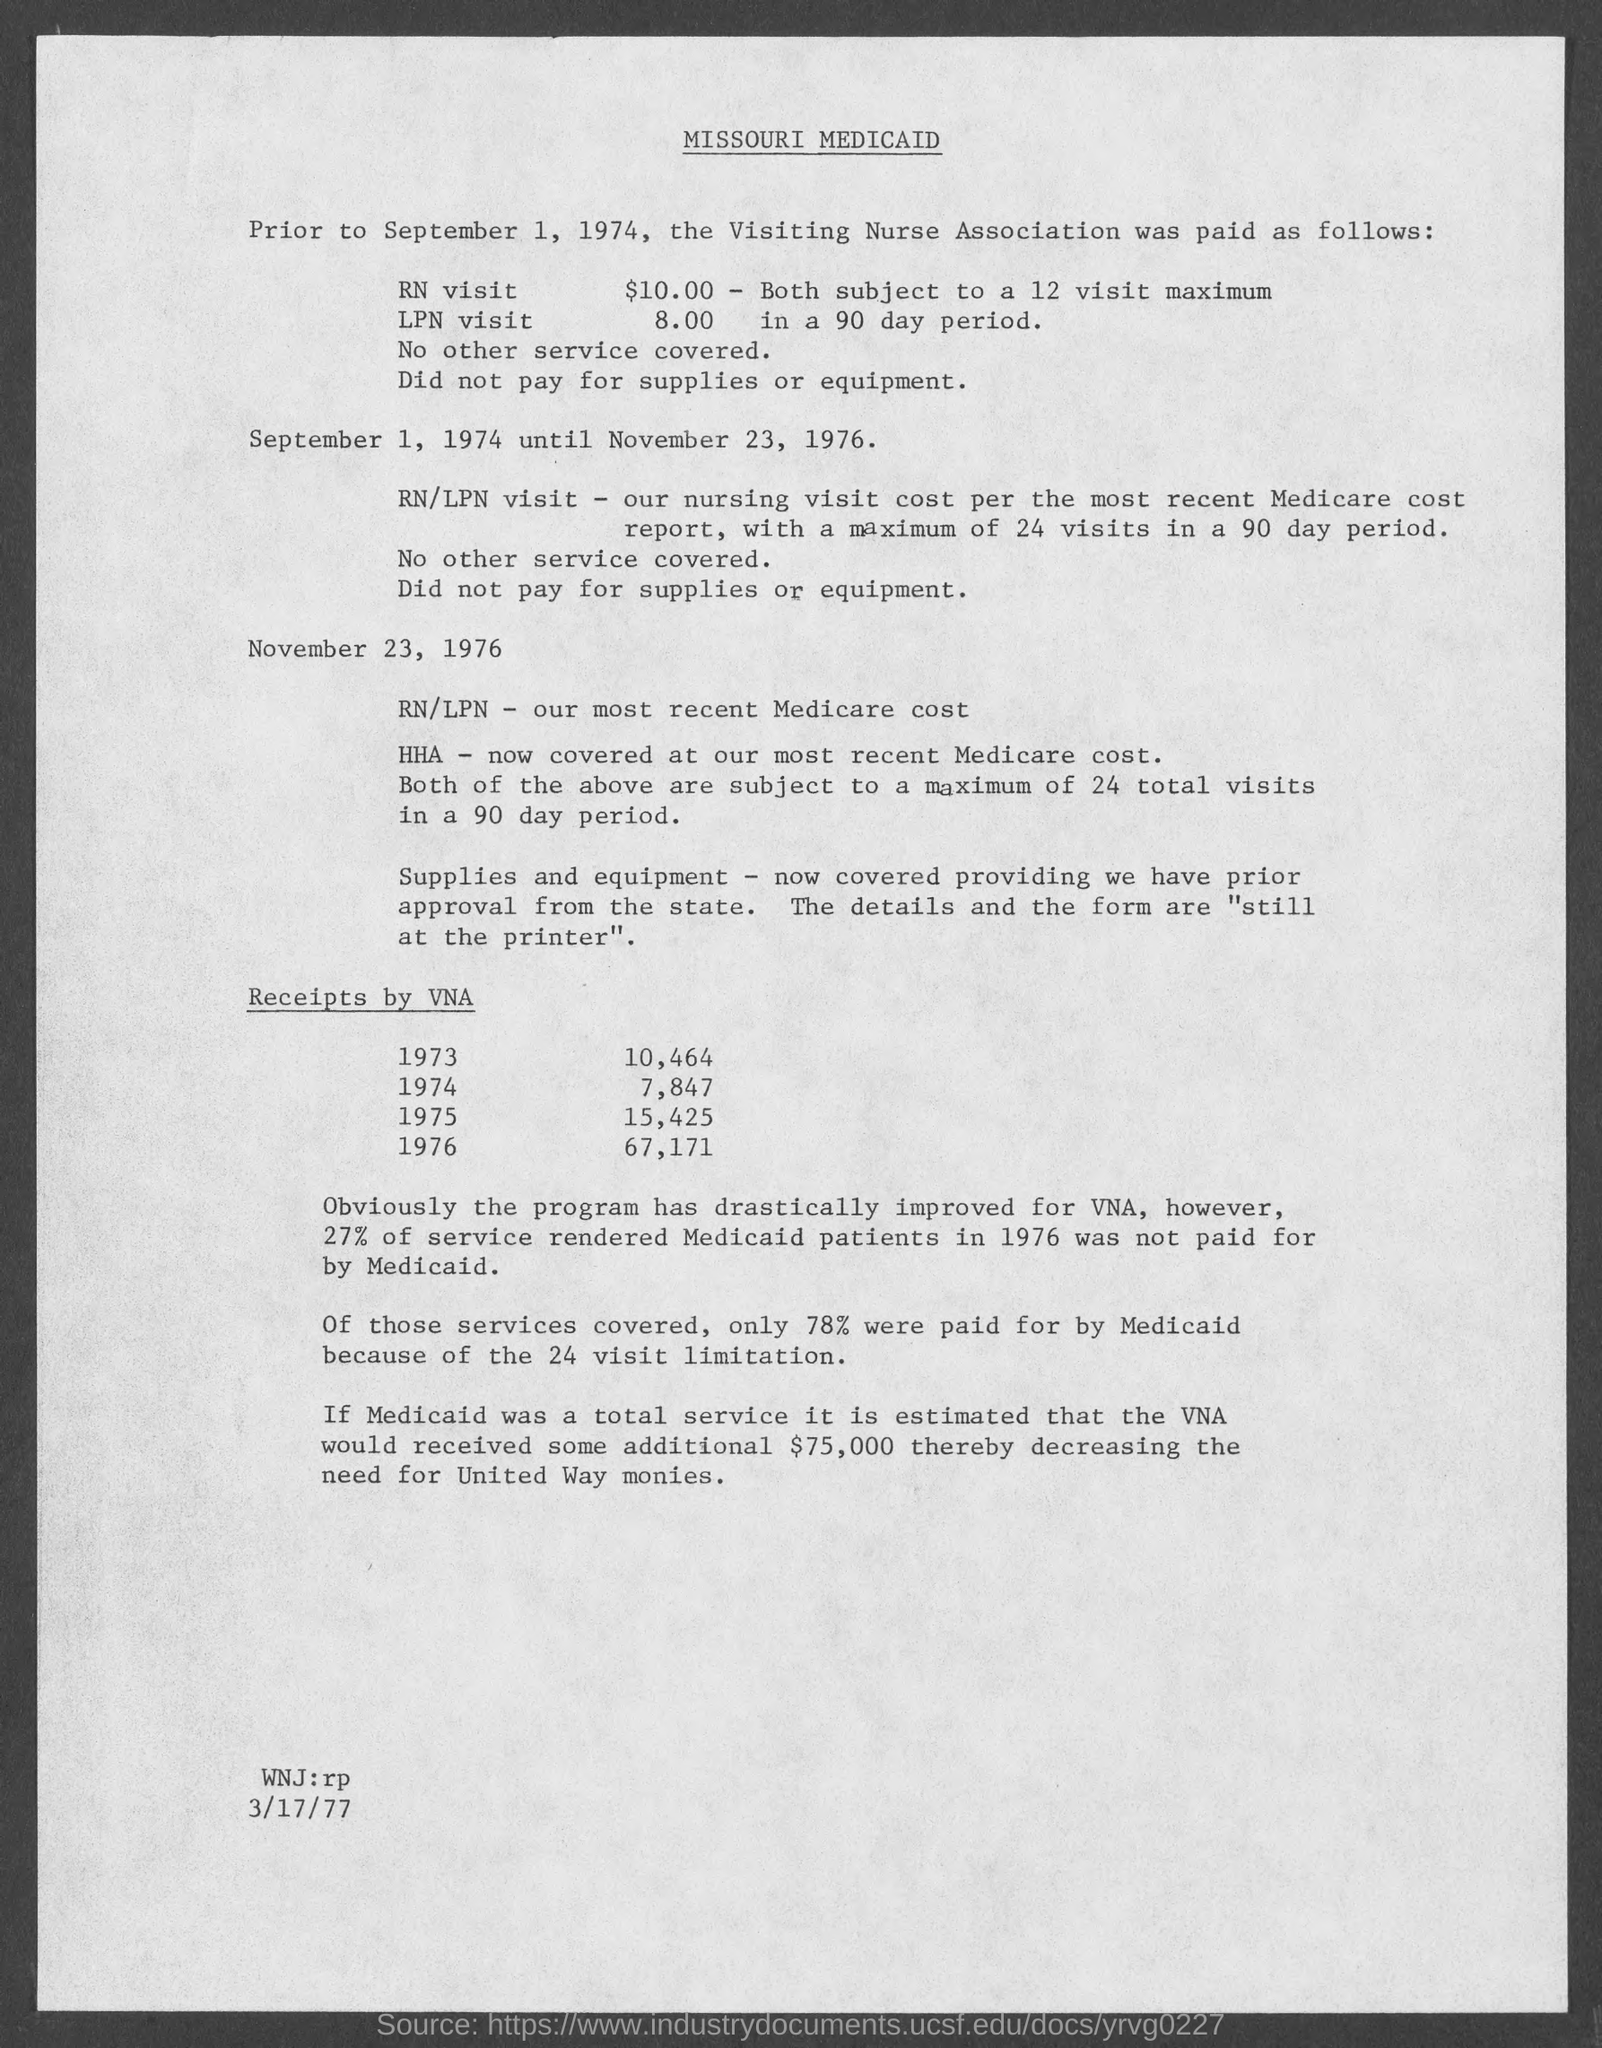What is the date mentioned at the bottom of the document?
Your answer should be very brief. 3/17/77. What is the first date mentioned in the document?
Keep it short and to the point. September 1, 1974. 